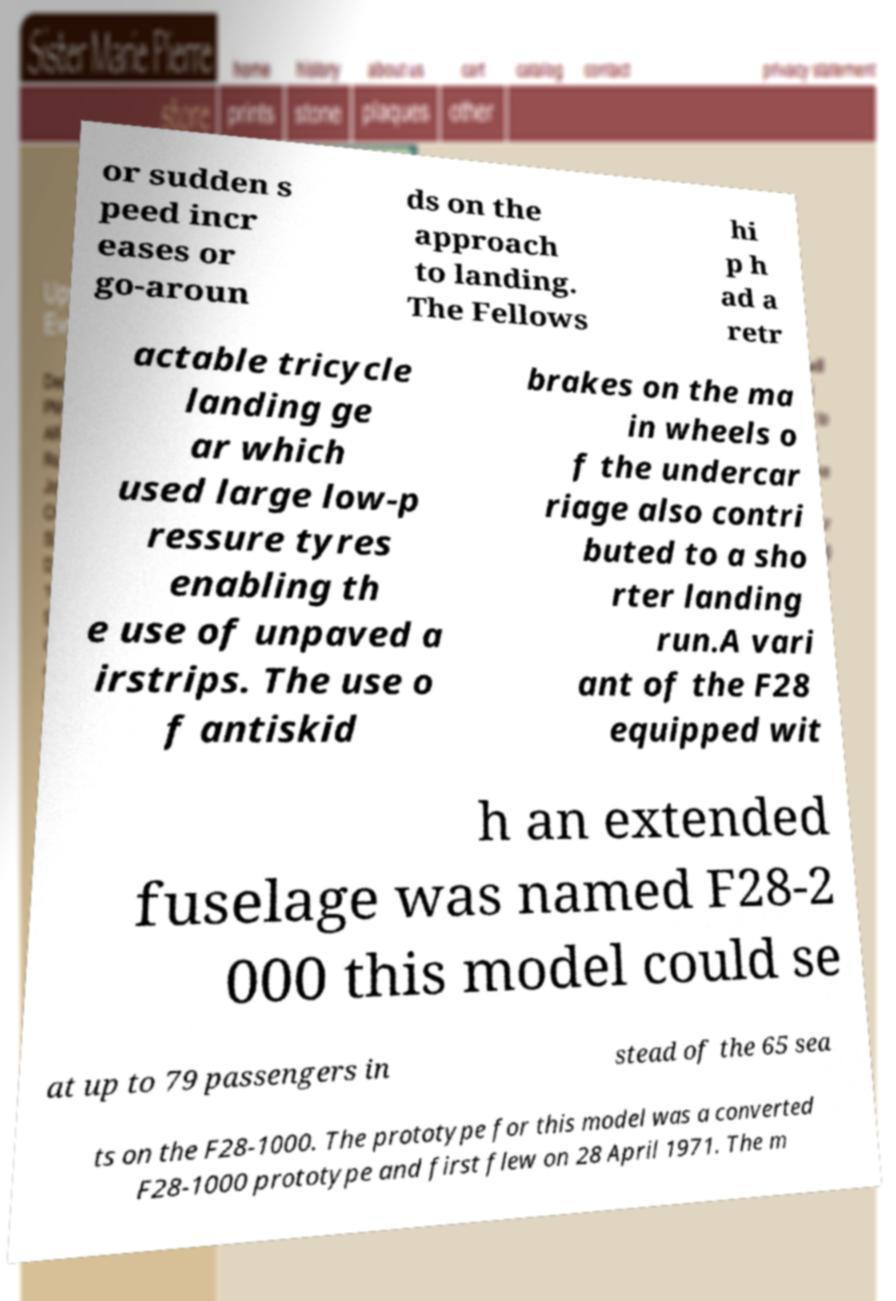Could you extract and type out the text from this image? or sudden s peed incr eases or go-aroun ds on the approach to landing. The Fellows hi p h ad a retr actable tricycle landing ge ar which used large low-p ressure tyres enabling th e use of unpaved a irstrips. The use o f antiskid brakes on the ma in wheels o f the undercar riage also contri buted to a sho rter landing run.A vari ant of the F28 equipped wit h an extended fuselage was named F28-2 000 this model could se at up to 79 passengers in stead of the 65 sea ts on the F28-1000. The prototype for this model was a converted F28-1000 prototype and first flew on 28 April 1971. The m 